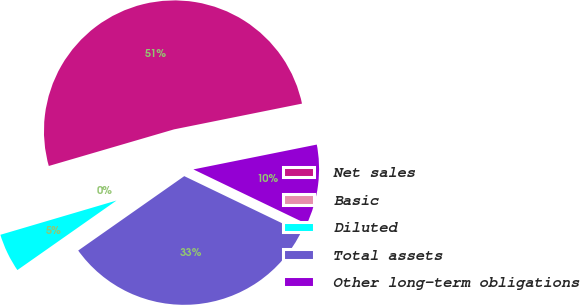Convert chart. <chart><loc_0><loc_0><loc_500><loc_500><pie_chart><fcel>Net sales<fcel>Basic<fcel>Diluted<fcel>Total assets<fcel>Other long-term obligations<nl><fcel>51.36%<fcel>0.04%<fcel>5.17%<fcel>33.12%<fcel>10.3%<nl></chart> 